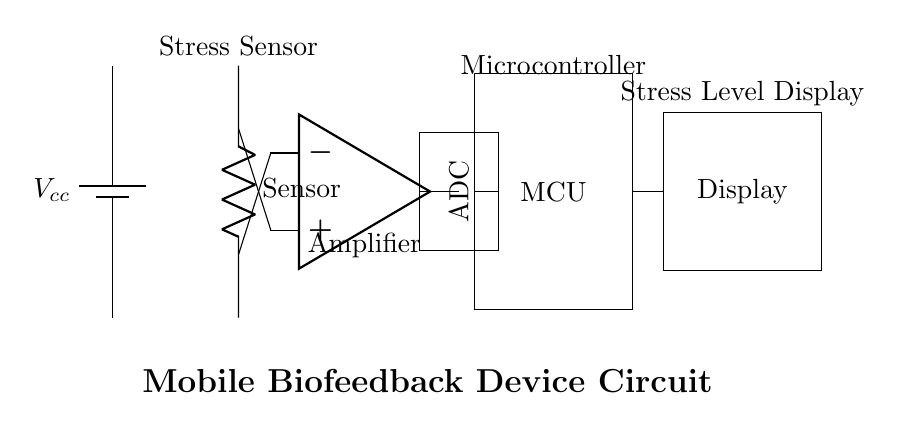What is the main function of the sensor? The sensor is designed to measure stress levels by detecting physiological signals. As indicated by the label "Sensor" in the circuit diagram, it directly interfaces with the rest of the circuitry for processing.
Answer: Measure stress levels Which component amplifies the signal from the sensor? The amplifier is the component responsible for increasing the magnitude of the signals received from the sensor. It is labeled "Amplifier" in the circuit diagram and is connected to both the sensor and the next stage of the circuit.
Answer: Amplifier What type of component is used to convert analog signals to digital signals? The Analog-to-Digital Converter (ADC) is the component that performs this conversion. In the circuit, it is represented as a rectangle labeled "ADC," following the amplifier and before the microcontroller.
Answer: ADC How many main components are involved in this circuit? There are four main components involved: the sensor, the amplifier, the microcontroller, and the display. Counting each distinct labeled part, we confirm the total number of components.
Answer: Four What is the output of the microcontroller? The output of the microcontroller connects to the display, which shows the processed data from the ADC. The microcontroller gathers and formats the data derived from the amplified sensor signal and then sends it to the display for visualization.
Answer: Display What is the role of the microcontroller in the circuit? The microcontroller processes the digital signals from the ADC and controls the operations of the device, including managing how stress levels are displayed. It is crucial for converting the measured data into a user-friendly format presented on the display.
Answer: Control processing What is the power supply voltage represented in the circuit? The voltage supply is labeled as Vcc in the circuit diagram, which typically represents the positive voltage supply required to power the components. The specific value isn't indicated, but it is understood as a standard operating voltage for such circuits.
Answer: Vcc 